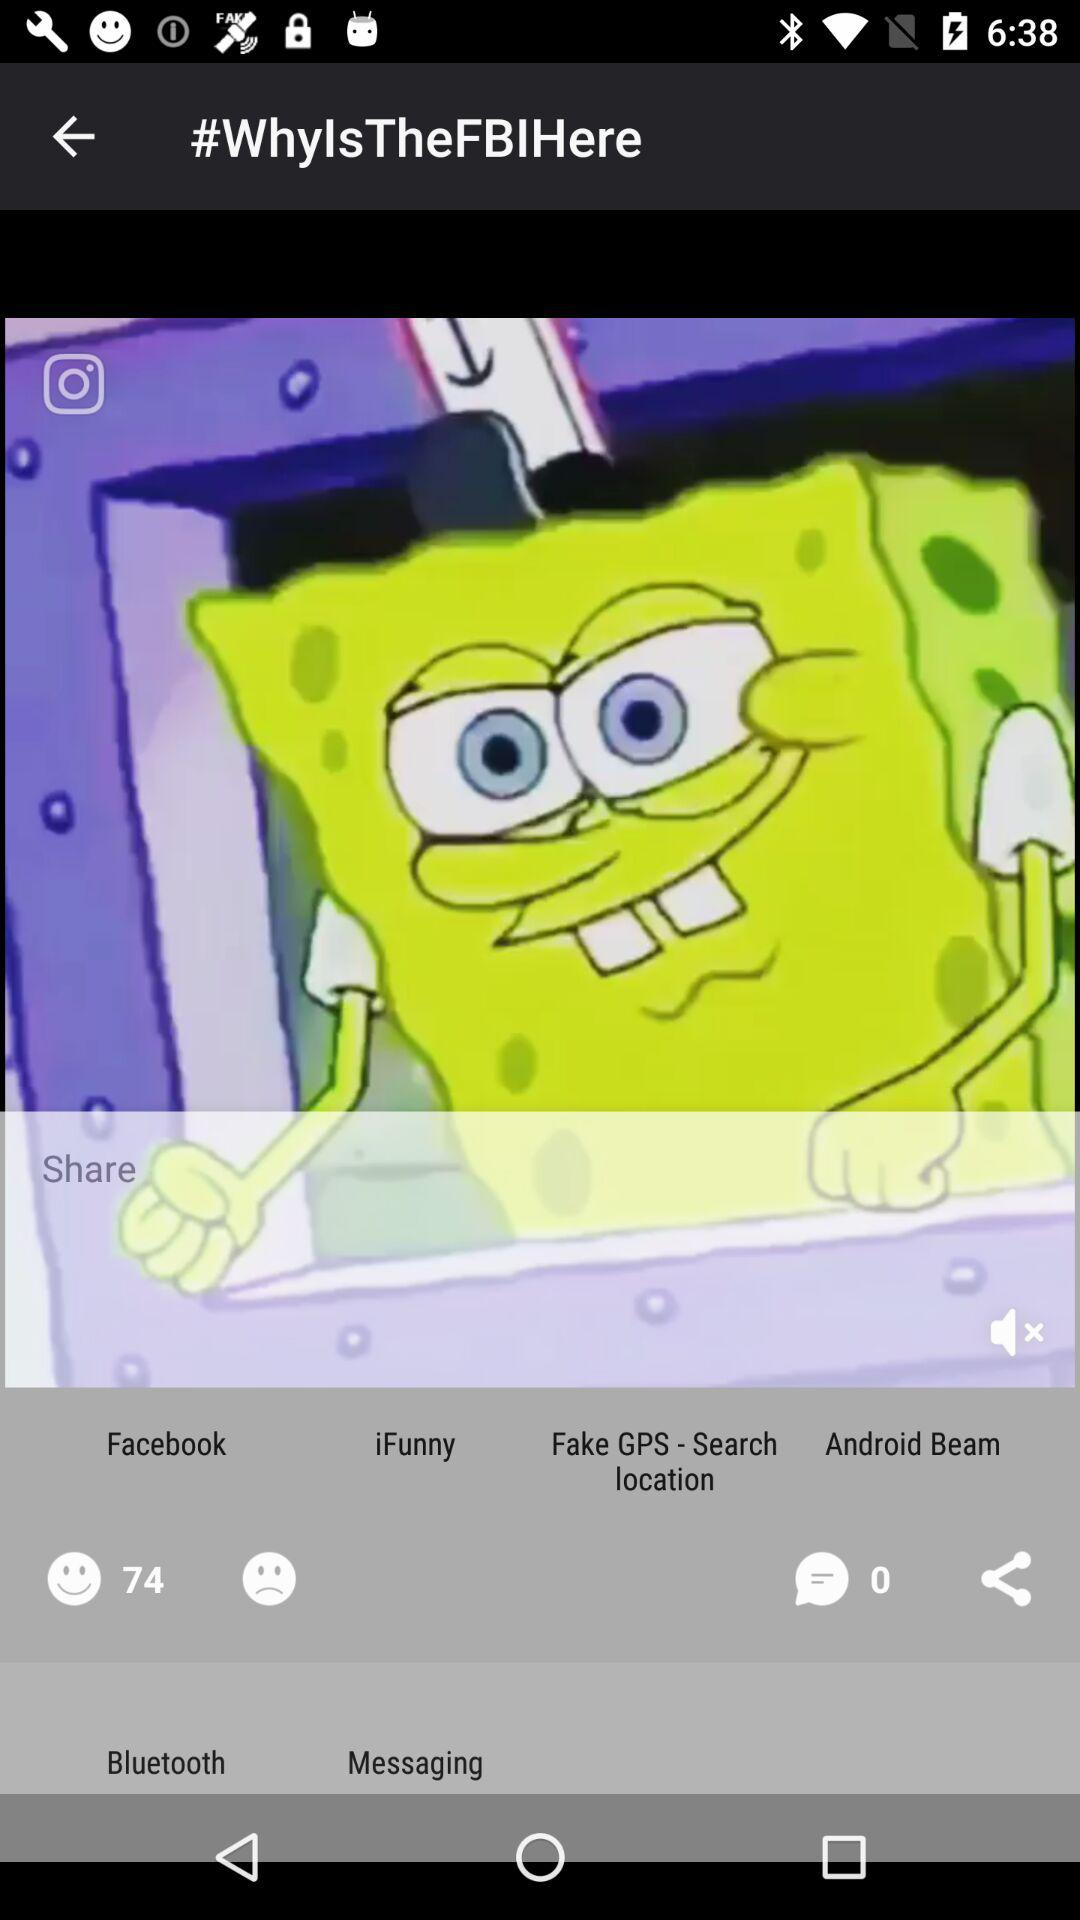What is the number of likes? The number of likes is 74. 